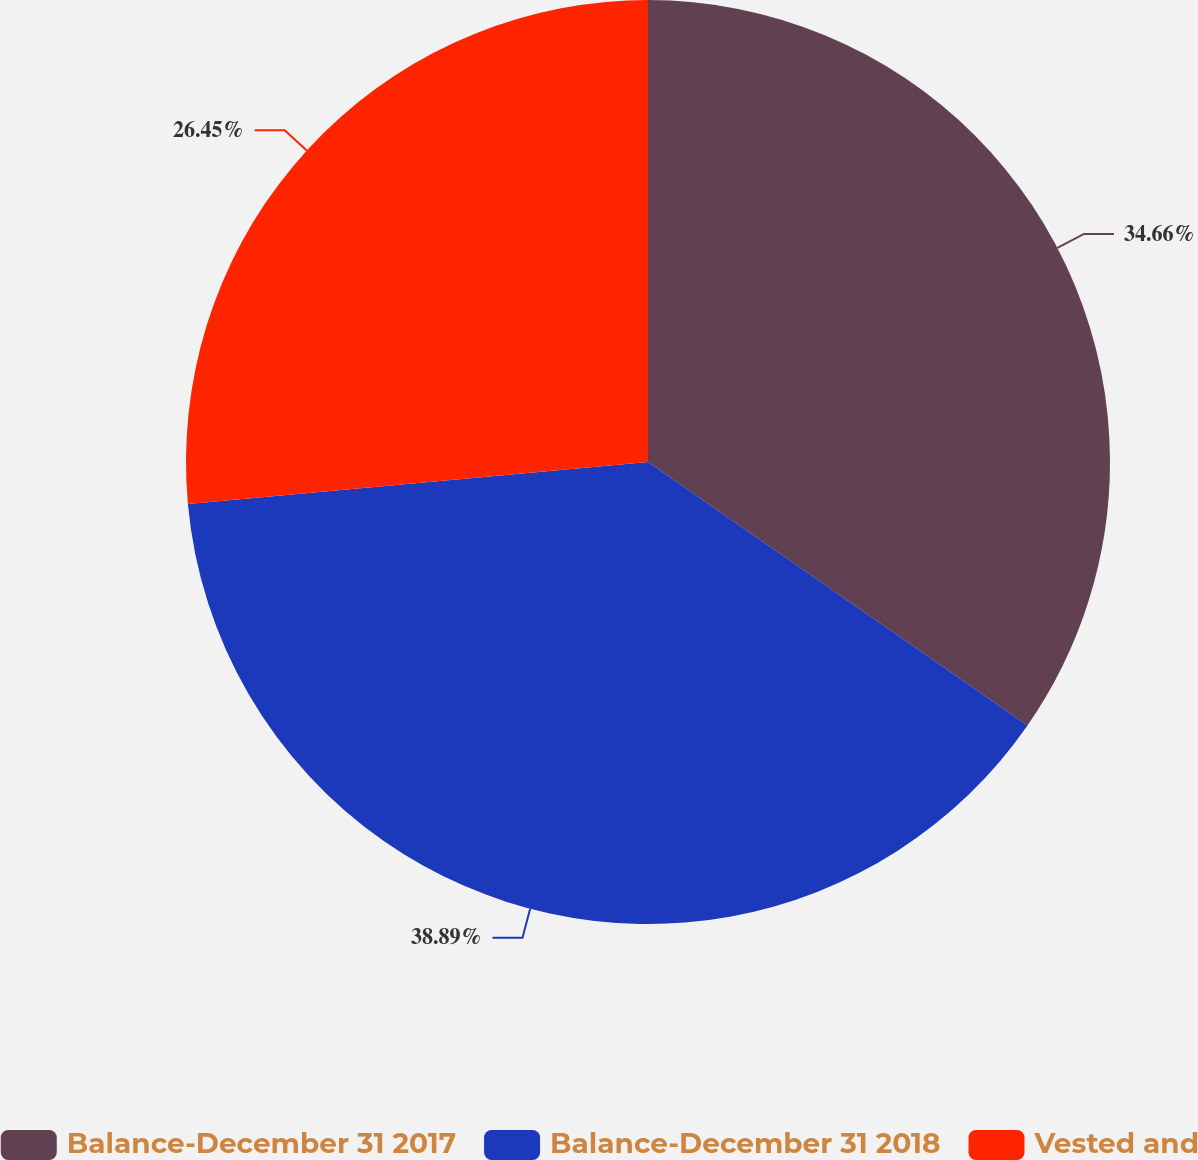<chart> <loc_0><loc_0><loc_500><loc_500><pie_chart><fcel>Balance-December 31 2017<fcel>Balance-December 31 2018<fcel>Vested and<nl><fcel>34.66%<fcel>38.89%<fcel>26.45%<nl></chart> 